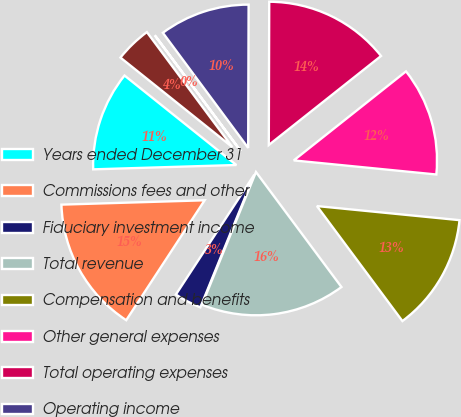<chart> <loc_0><loc_0><loc_500><loc_500><pie_chart><fcel>Years ended December 31<fcel>Commissions fees and other<fcel>Fiduciary investment income<fcel>Total revenue<fcel>Compensation and benefits<fcel>Other general expenses<fcel>Total operating expenses<fcel>Operating income<fcel>Interest income<fcel>Interest expense<nl><fcel>11.22%<fcel>15.3%<fcel>3.07%<fcel>16.32%<fcel>13.26%<fcel>12.24%<fcel>14.28%<fcel>10.2%<fcel>0.02%<fcel>4.09%<nl></chart> 